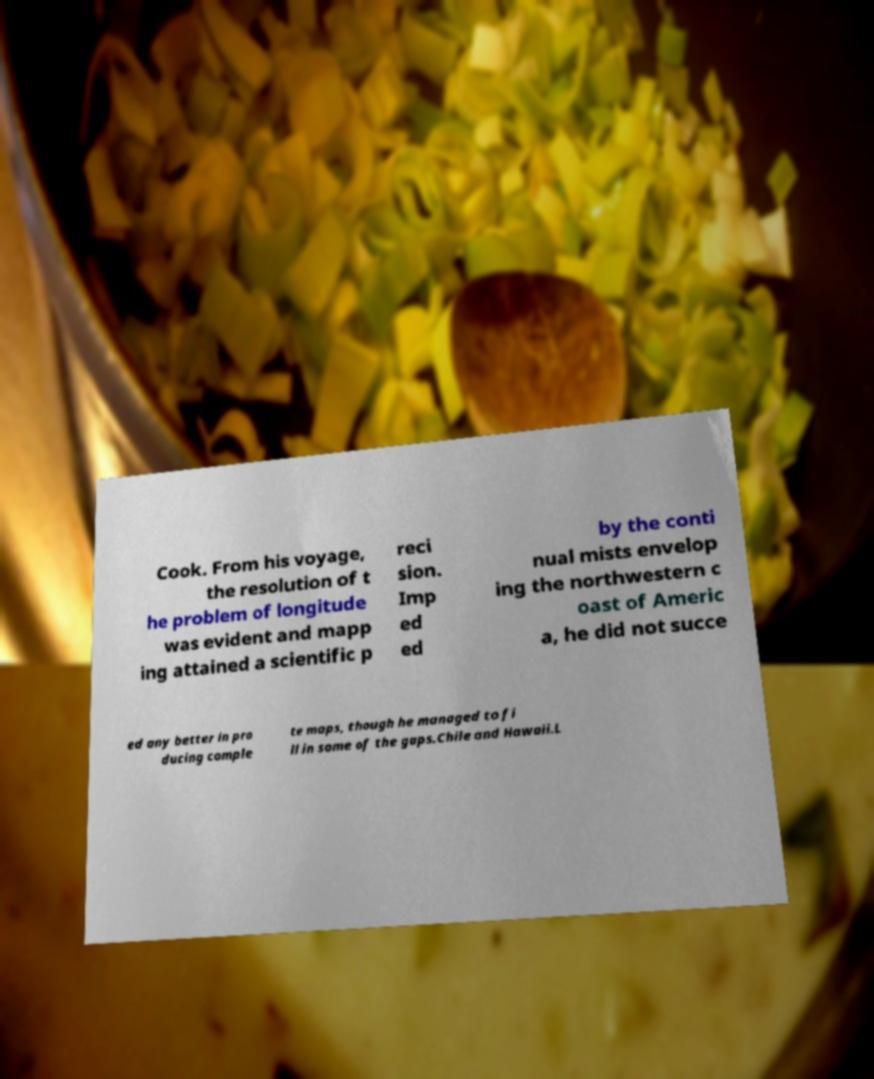I need the written content from this picture converted into text. Can you do that? Cook. From his voyage, the resolution of t he problem of longitude was evident and mapp ing attained a scientific p reci sion. Imp ed ed by the conti nual mists envelop ing the northwestern c oast of Americ a, he did not succe ed any better in pro ducing comple te maps, though he managed to fi ll in some of the gaps.Chile and Hawaii.L 